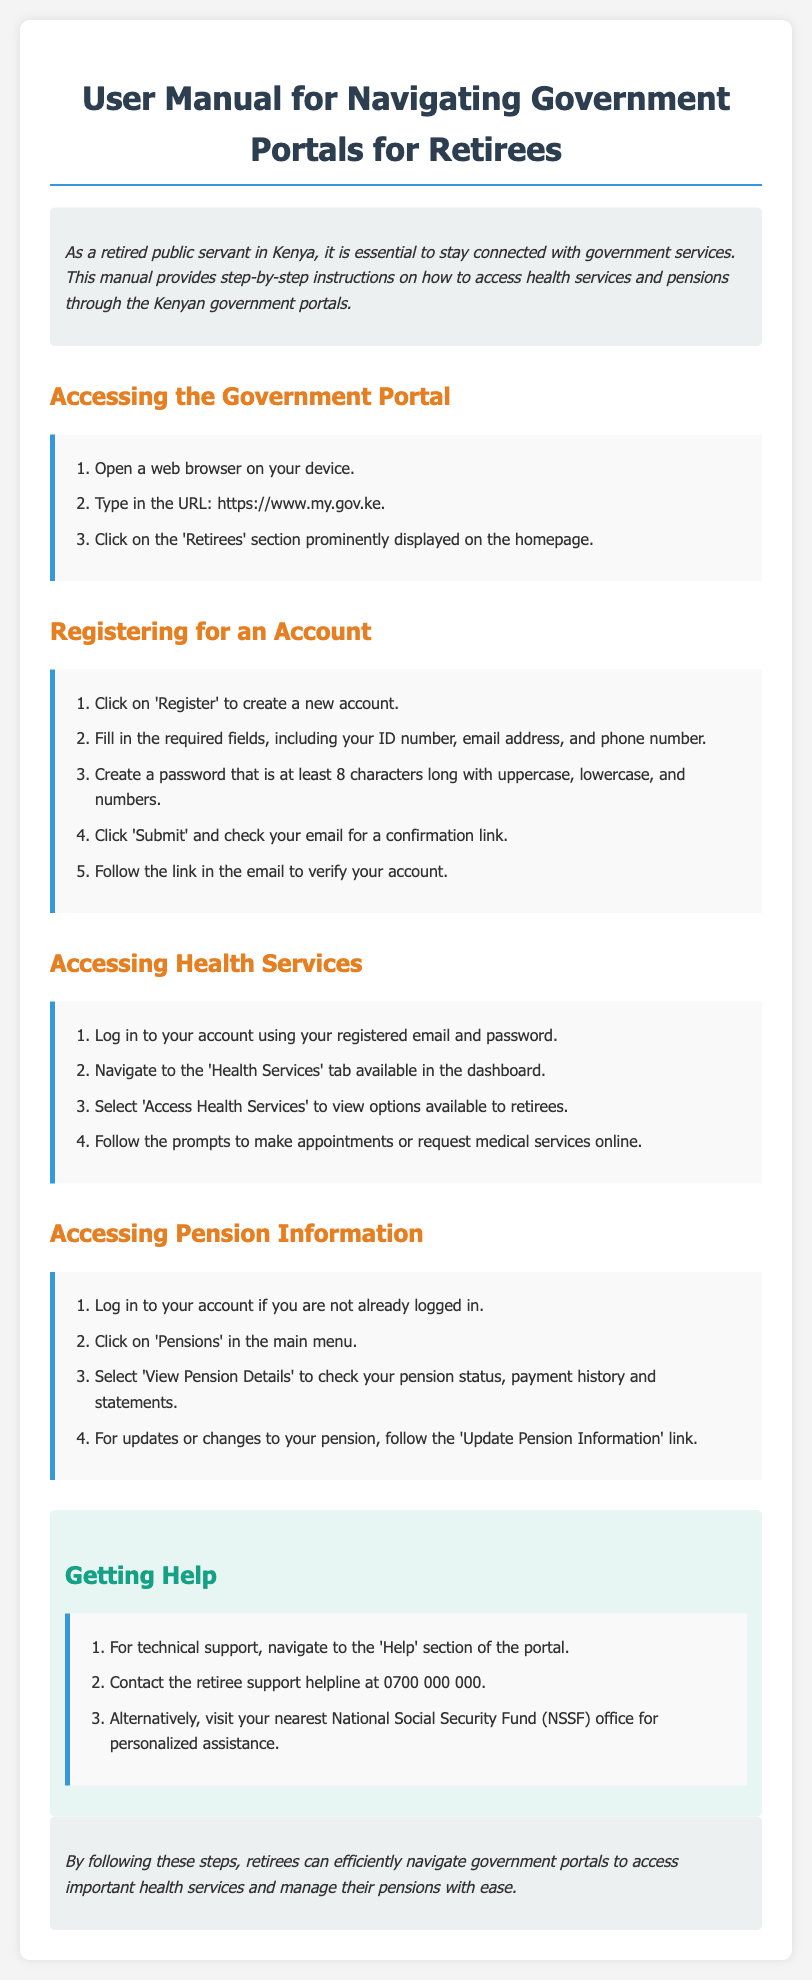What is the URL for the government portal? The URL provided in the document is where retirees can access government services online.
Answer: https://www.my.gov.ke How many characters must the password contain? The document specifies a requirement for password security during account registration.
Answer: 8 characters What section should you click on to access health services? This action is part of the step-by-step instructions for retirees seeking medical services.
Answer: Health Services What is the contact number for the retiree support helpline? The helpline number is mentioned in the help section for technical support and personal assistance.
Answer: 0700 000 000 What is the first step to register for an account? This question refers to the initial action required for accessing the portal's services.
Answer: Click on 'Register' Where can you find your pension details? This question pertains to accessing specific information regarding one's pension status.
Answer: Pensions 